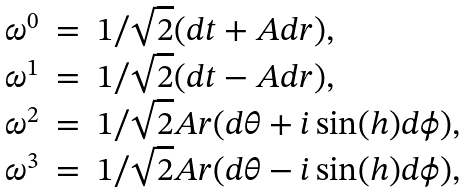Convert formula to latex. <formula><loc_0><loc_0><loc_500><loc_500>\begin{array} { l c l } \omega ^ { 0 } & = & 1 / \sqrt { 2 } ( d t + A d r ) , \\ \omega ^ { 1 } & = & 1 / \sqrt { 2 } ( d t - A d r ) , \\ \omega ^ { 2 } & = & 1 / \sqrt { 2 } A r ( d \theta + i \sin ( h ) d \phi ) , \\ \omega ^ { 3 } & = & 1 / \sqrt { 2 } A r ( d \theta - i \sin ( h ) d \phi ) , \end{array}</formula> 